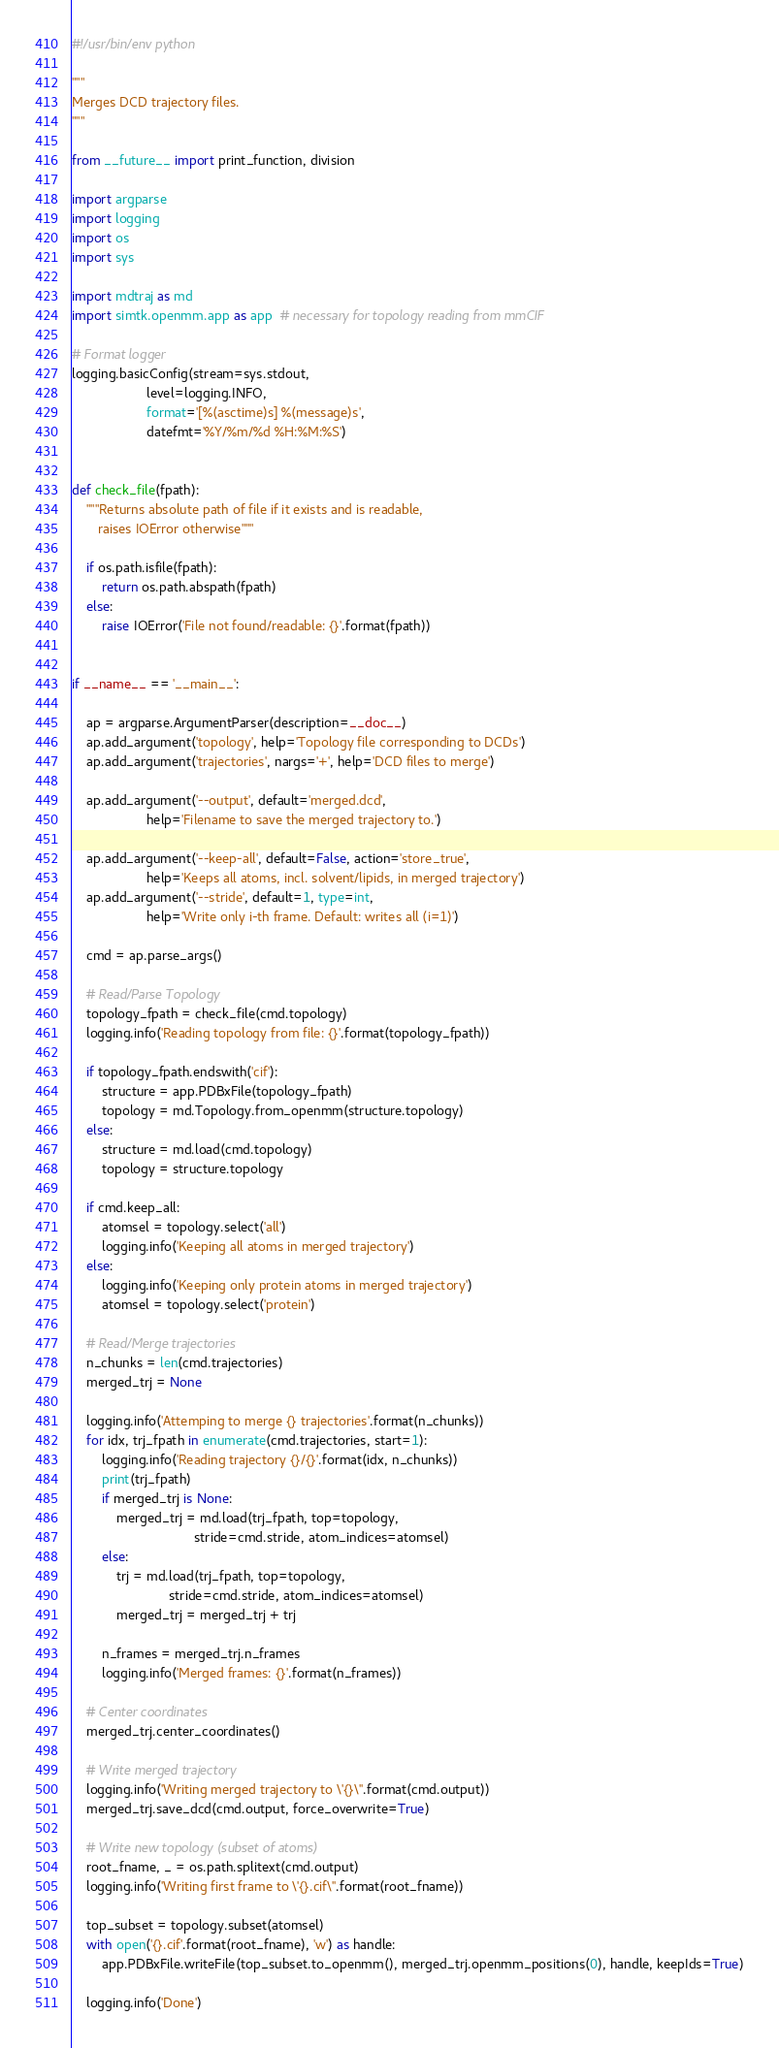<code> <loc_0><loc_0><loc_500><loc_500><_Python_>#!/usr/bin/env python

"""
Merges DCD trajectory files.
"""

from __future__ import print_function, division

import argparse
import logging
import os
import sys

import mdtraj as md
import simtk.openmm.app as app  # necessary for topology reading from mmCIF

# Format logger
logging.basicConfig(stream=sys.stdout,
                    level=logging.INFO,
                    format='[%(asctime)s] %(message)s',
                    datefmt='%Y/%m/%d %H:%M:%S')


def check_file(fpath):
    """Returns absolute path of file if it exists and is readable,
       raises IOError otherwise"""

    if os.path.isfile(fpath):
        return os.path.abspath(fpath)
    else:
        raise IOError('File not found/readable: {}'.format(fpath))


if __name__ == '__main__':

    ap = argparse.ArgumentParser(description=__doc__)
    ap.add_argument('topology', help='Topology file corresponding to DCDs')
    ap.add_argument('trajectories', nargs='+', help='DCD files to merge')

    ap.add_argument('--output', default='merged.dcd',
                    help='Filename to save the merged trajectory to.')

    ap.add_argument('--keep-all', default=False, action='store_true',
                    help='Keeps all atoms, incl. solvent/lipids, in merged trajectory')
    ap.add_argument('--stride', default=1, type=int,
                    help='Write only i-th frame. Default: writes all (i=1)')

    cmd = ap.parse_args()

    # Read/Parse Topology
    topology_fpath = check_file(cmd.topology)
    logging.info('Reading topology from file: {}'.format(topology_fpath))

    if topology_fpath.endswith('cif'):
        structure = app.PDBxFile(topology_fpath)
        topology = md.Topology.from_openmm(structure.topology)
    else:
        structure = md.load(cmd.topology)
        topology = structure.topology

    if cmd.keep_all:
        atomsel = topology.select('all')
        logging.info('Keeping all atoms in merged trajectory')
    else:
        logging.info('Keeping only protein atoms in merged trajectory')
        atomsel = topology.select('protein')

    # Read/Merge trajectories
    n_chunks = len(cmd.trajectories)
    merged_trj = None

    logging.info('Attemping to merge {} trajectories'.format(n_chunks))
    for idx, trj_fpath in enumerate(cmd.trajectories, start=1):
        logging.info('Reading trajectory {}/{}'.format(idx, n_chunks))
        print(trj_fpath)
        if merged_trj is None:
            merged_trj = md.load(trj_fpath, top=topology,
                                 stride=cmd.stride, atom_indices=atomsel)
        else:
            trj = md.load(trj_fpath, top=topology,
                          stride=cmd.stride, atom_indices=atomsel)
            merged_trj = merged_trj + trj

        n_frames = merged_trj.n_frames
        logging.info('Merged frames: {}'.format(n_frames))

    # Center coordinates
    merged_trj.center_coordinates()

    # Write merged trajectory
    logging.info('Writing merged trajectory to \'{}\''.format(cmd.output))
    merged_trj.save_dcd(cmd.output, force_overwrite=True)

    # Write new topology (subset of atoms)
    root_fname, _ = os.path.splitext(cmd.output)
    logging.info('Writing first frame to \'{}.cif\''.format(root_fname))

    top_subset = topology.subset(atomsel)
    with open('{}.cif'.format(root_fname), 'w') as handle:
        app.PDBxFile.writeFile(top_subset.to_openmm(), merged_trj.openmm_positions(0), handle, keepIds=True)

    logging.info('Done')
</code> 